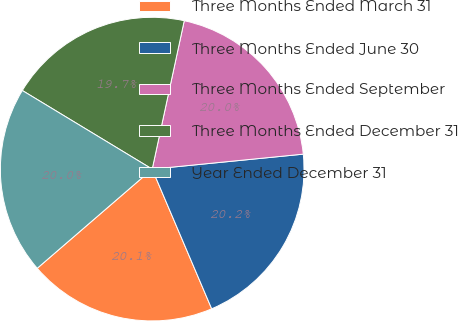Convert chart. <chart><loc_0><loc_0><loc_500><loc_500><pie_chart><fcel>Three Months Ended March 31<fcel>Three Months Ended June 30<fcel>Three Months Ended September<fcel>Three Months Ended December 31<fcel>Year Ended December 31<nl><fcel>20.08%<fcel>20.16%<fcel>20.04%<fcel>19.72%<fcel>19.99%<nl></chart> 